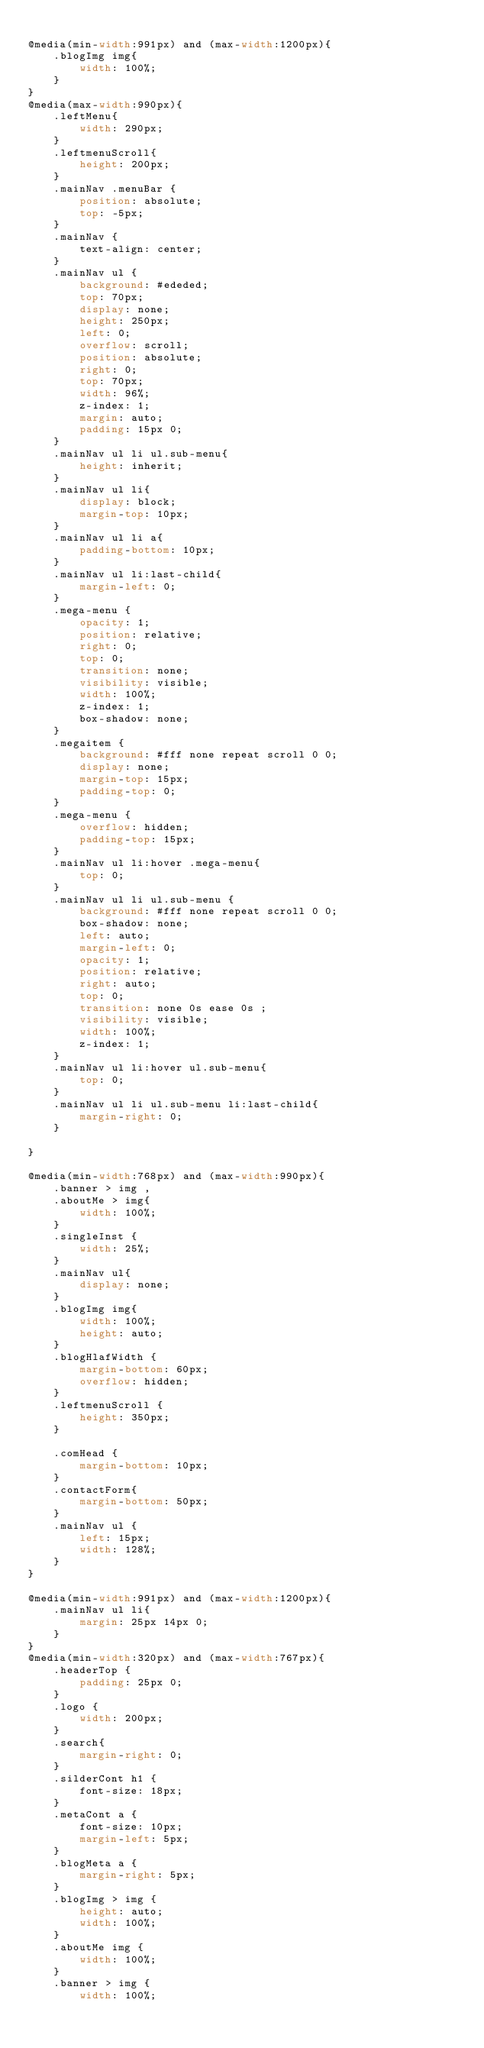<code> <loc_0><loc_0><loc_500><loc_500><_CSS_>
@media(min-width:991px) and (max-width:1200px){
    .blogImg img{
        width: 100%;
    }
}
@media(max-width:990px){
    .leftMenu{
        width: 290px;
    }
    .leftmenuScroll{
        height: 200px;
    }
    .mainNav .menuBar {
        position: absolute;
        top: -5px;
    }
    .mainNav {
        text-align: center;
    }
    .mainNav ul {
        background: #ededed;
        top: 70px;
        display: none;
        height: 250px;
        left: 0;
        overflow: scroll;
        position: absolute;
        right: 0;
        top: 70px;
        width: 96%;
        z-index: 1;
        margin: auto;
        padding: 15px 0;
    }
    .mainNav ul li ul.sub-menu{
        height: inherit;
    }
    .mainNav ul li{
        display: block;
        margin-top: 10px;
    }
    .mainNav ul li a{
        padding-bottom: 10px;
    }
    .mainNav ul li:last-child{
        margin-left: 0;
    }
    .mega-menu {
        opacity: 1;
        position: relative;
        right: 0;
        top: 0;
        transition: none;
        visibility: visible;
        width: 100%;
        z-index: 1;
        box-shadow: none;
    }
    .megaitem {
        background: #fff none repeat scroll 0 0;
        display: none;
        margin-top: 15px;
        padding-top: 0;
    }
    .mega-menu {
        overflow: hidden;
        padding-top: 15px;
    }
    .mainNav ul li:hover .mega-menu{
        top: 0;
    }
    .mainNav ul li ul.sub-menu {
        background: #fff none repeat scroll 0 0;
        box-shadow: none;
        left: auto;
        margin-left: 0;
        opacity: 1;
        position: relative;
        right: auto;
        top: 0;
        transition: none 0s ease 0s ;
        visibility: visible;
        width: 100%;
        z-index: 1;
    }
    .mainNav ul li:hover ul.sub-menu{
        top: 0;
    }
    .mainNav ul li ul.sub-menu li:last-child{
        margin-right: 0;
    }

}

@media(min-width:768px) and (max-width:990px){
    .banner > img ,
    .aboutMe > img{
        width: 100%;
    }
    .singleInst {
        width: 25%;
    }
    .mainNav ul{
        display: none;
    }
    .blogImg img{
        width: 100%;
        height: auto;
    }
    .blogHlafWidth {
        margin-bottom: 60px;
        overflow: hidden;
    }
    .leftmenuScroll {
        height: 350px;
    }
    
    .comHead {
        margin-bottom: 10px;
    }
    .contactForm{
        margin-bottom: 50px;
    }
    .mainNav ul {
        left: 15px;
        width: 128%;
    }
}

@media(min-width:991px) and (max-width:1200px){
    .mainNav ul li{
        margin: 25px 14px 0;
    }
}
@media(min-width:320px) and (max-width:767px){
    .headerTop {
        padding: 25px 0;
    }
    .logo {
        width: 200px;
    }
    .search{
        margin-right: 0;
    }
    .silderCont h1 {
        font-size: 18px;
    }
    .metaCont a {
        font-size: 10px;
        margin-left: 5px;
    }
    .blogMeta a {
        margin-right: 5px;
    }
    .blogImg > img {
        height: auto;
        width: 100%;
    }
    .aboutMe img {
        width: 100%;
    }
    .banner > img {
        width: 100%;</code> 